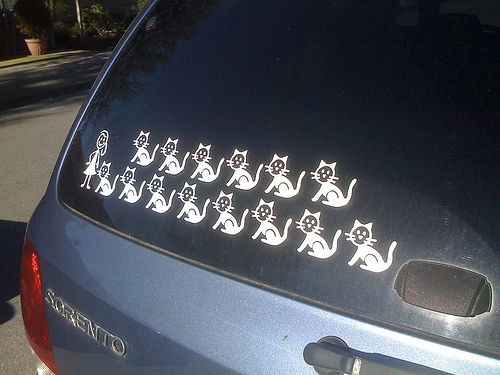<image>
Can you confirm if the woman is on the window? Yes. Looking at the image, I can see the woman is positioned on top of the window, with the window providing support. 